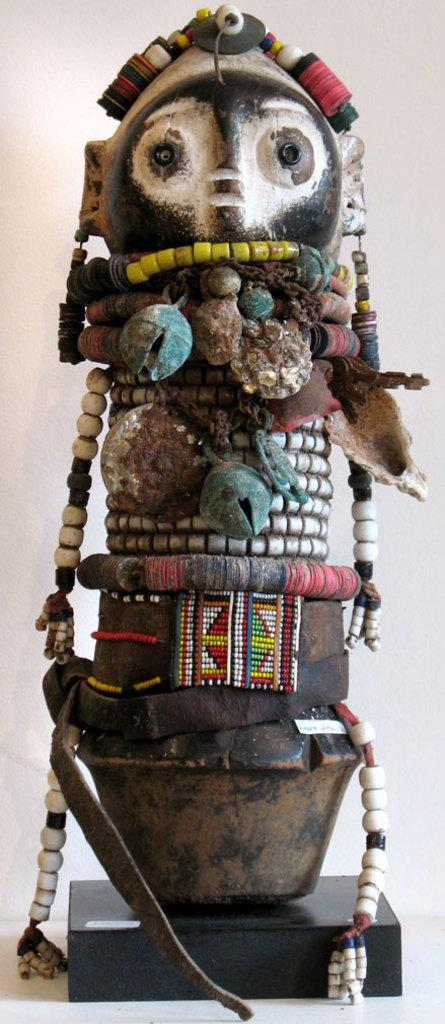What is the main subject in the image? There is a statue in the image. What type of brick is used to construct the statue in the image? There is no information about the type of brick used to construct the statue in the image. Is the statue wearing a shirt in the image? There is no information about the statue wearing a shirt in the image. 